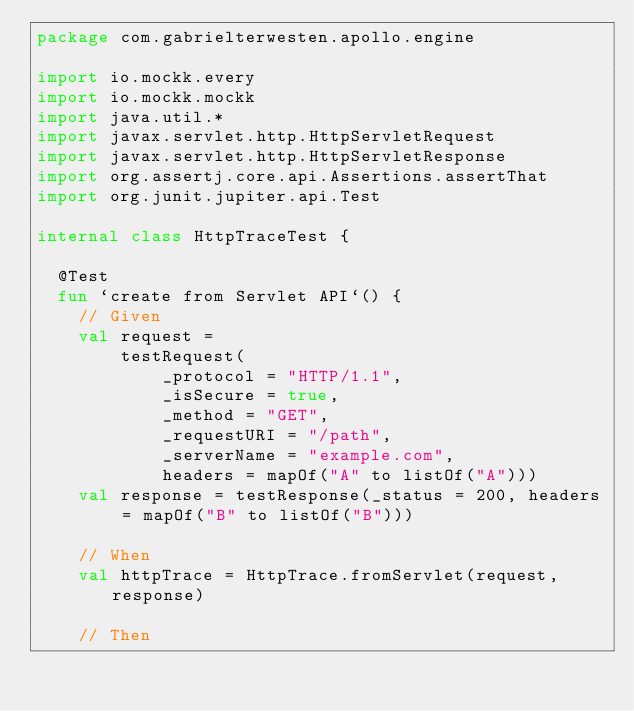<code> <loc_0><loc_0><loc_500><loc_500><_Kotlin_>package com.gabrielterwesten.apollo.engine

import io.mockk.every
import io.mockk.mockk
import java.util.*
import javax.servlet.http.HttpServletRequest
import javax.servlet.http.HttpServletResponse
import org.assertj.core.api.Assertions.assertThat
import org.junit.jupiter.api.Test

internal class HttpTraceTest {

  @Test
  fun `create from Servlet API`() {
    // Given
    val request =
        testRequest(
            _protocol = "HTTP/1.1",
            _isSecure = true,
            _method = "GET",
            _requestURI = "/path",
            _serverName = "example.com",
            headers = mapOf("A" to listOf("A")))
    val response = testResponse(_status = 200, headers = mapOf("B" to listOf("B")))

    // When
    val httpTrace = HttpTrace.fromServlet(request, response)

    // Then</code> 